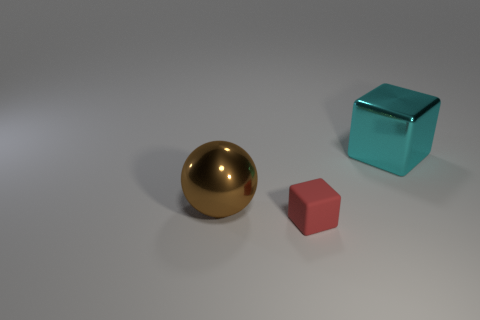Add 3 big cylinders. How many objects exist? 6 Subtract all blocks. How many objects are left? 1 Subtract 1 cyan cubes. How many objects are left? 2 Subtract all tiny green things. Subtract all cyan shiny cubes. How many objects are left? 2 Add 1 red blocks. How many red blocks are left? 2 Add 1 cyan shiny objects. How many cyan shiny objects exist? 2 